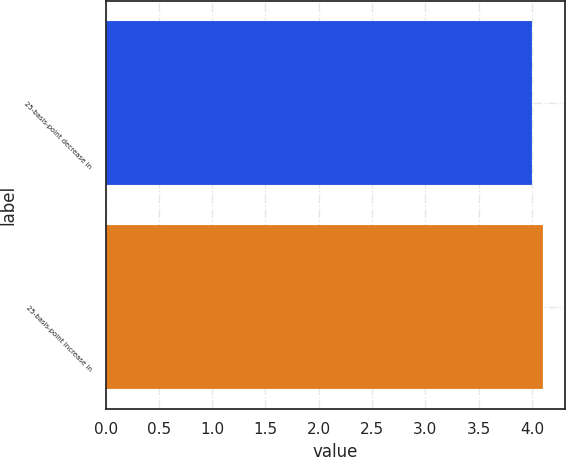Convert chart to OTSL. <chart><loc_0><loc_0><loc_500><loc_500><bar_chart><fcel>25-basis-point decrease in<fcel>25-basis-point increase in<nl><fcel>4<fcel>4.1<nl></chart> 